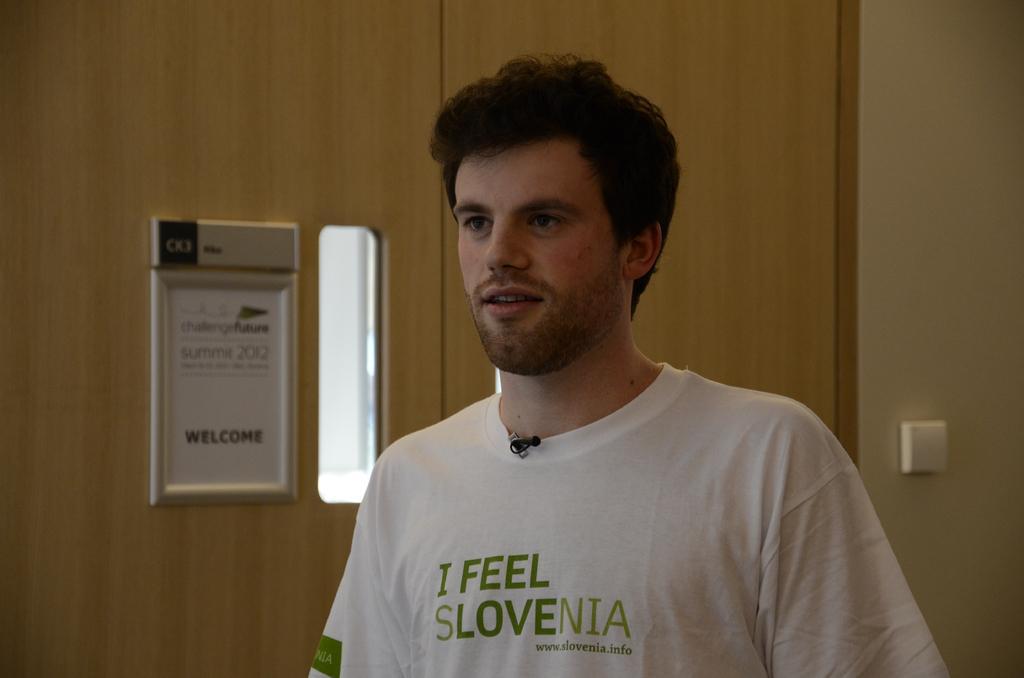Describe this image in one or two sentences. In this image in the center there is one person and in the background there is a door and board and wall, on the board there is text. 